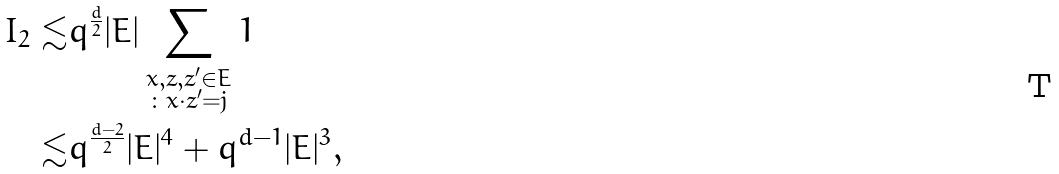<formula> <loc_0><loc_0><loc_500><loc_500>I _ { 2 } \lesssim & q ^ { \frac { d } { 2 } } | E | \sum _ { \substack { x , z , z ^ { \prime } \in E \\ \colon x \cdot z ^ { \prime } = j } } 1 \\ \lesssim & q ^ { \frac { d - 2 } { 2 } } | E | ^ { 4 } + q ^ { d - 1 } | E | ^ { 3 } ,</formula> 